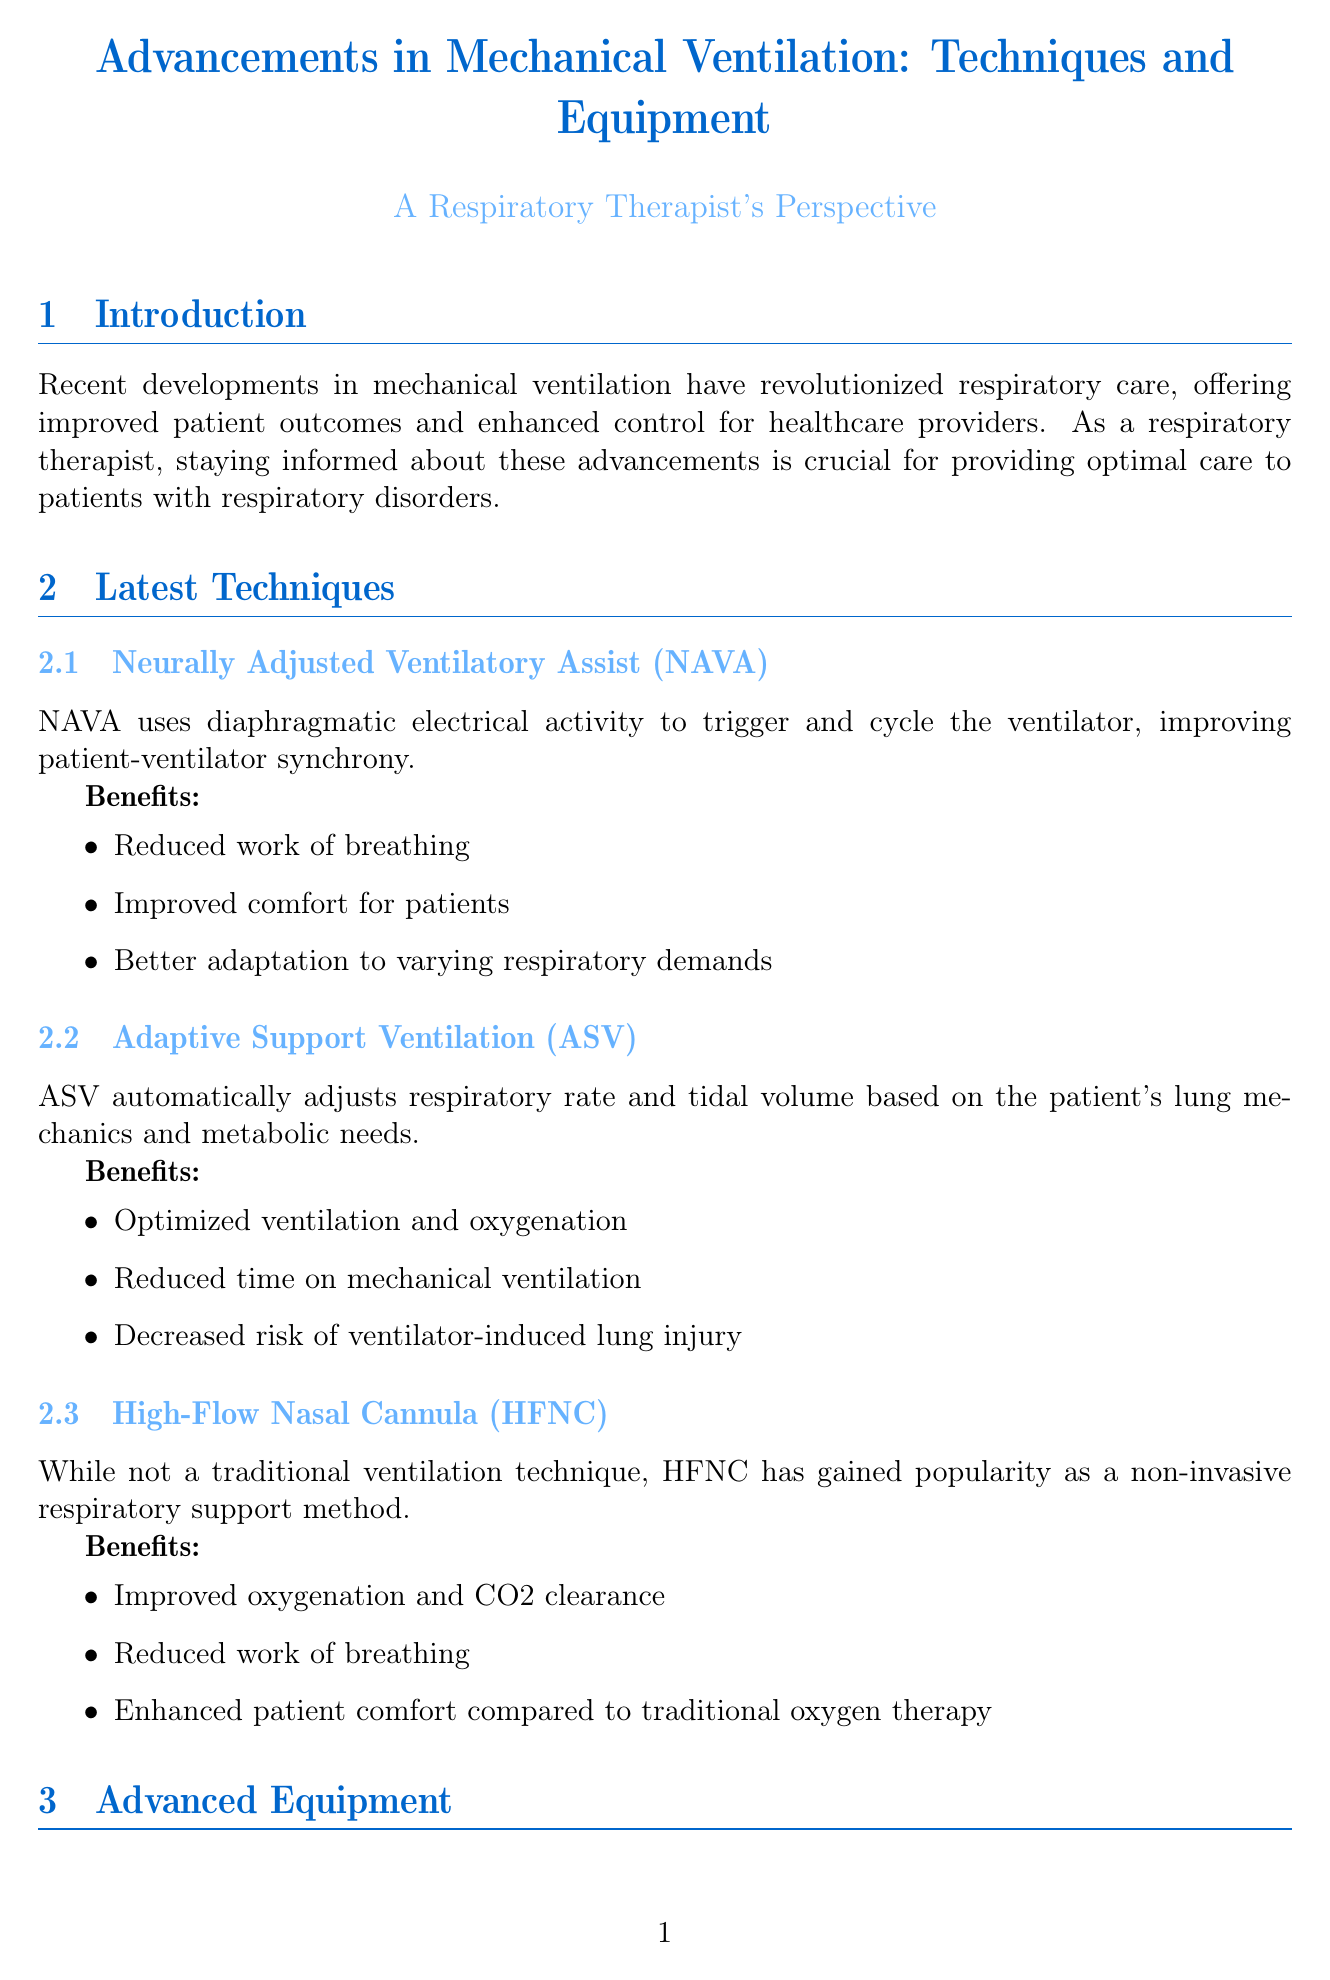what is the title of the report? The title of the report is clearly stated at the beginning of the document.
Answer: Advancements in Mechanical Ventilation: Techniques and Equipment what technique uses diaphragmatic electrical activity? The document mentions various techniques and indicates which one uses diaphragmatic electrical activity for ventilation.
Answer: Neurally Adjusted Ventilatory Assist (NAVA) which ventilator is recommended for transport situations? The document includes a section on equipment recommendations, specifying which ventilator is ideal for transport.
Answer: Philips Respironics V680 what are the benefits of Adaptive Support Ventilation? The document lists the benefits associated with Adaptive Support Ventilation in the section about latest techniques.
Answer: Optimized ventilation and oxygenation, reduced time on mechanical ventilation, decreased risk of ventilator-induced lung injury what is a recommendation for long-term ventilation? The document provides specific recommendations for equipment based on different care scenarios, including long-term ventilation.
Answer: Dräger Evita V800 which method is excellent for high-flow oxygen therapy? The document describes various techniques and identifies one that is suited for high-flow oxygen therapy.
Answer: High-Flow Nasal Cannula (HFNC) what is a consideration for pulmonologists mentioned in the report? The document includes a list of considerations for pulmonologists when selecting ventilation techniques and equipment.
Answer: Assess the specific needs of your patient population when selecting ventilation techniques and equipment how many advanced ventilators are discussed in the document? The document specifies the number of advanced ventilators covered in the advanced equipment section.
Answer: Three 